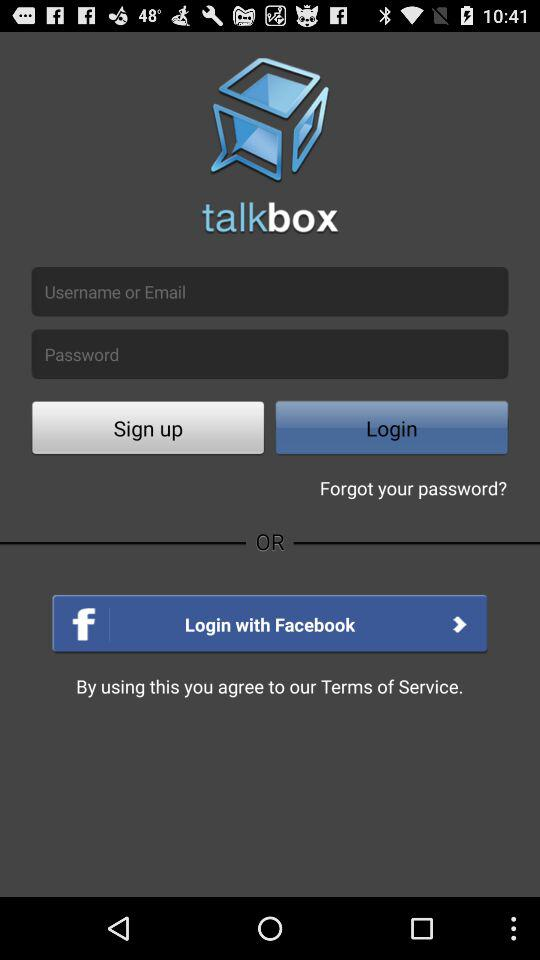Through what application can login be done? The application is "Facebook". 